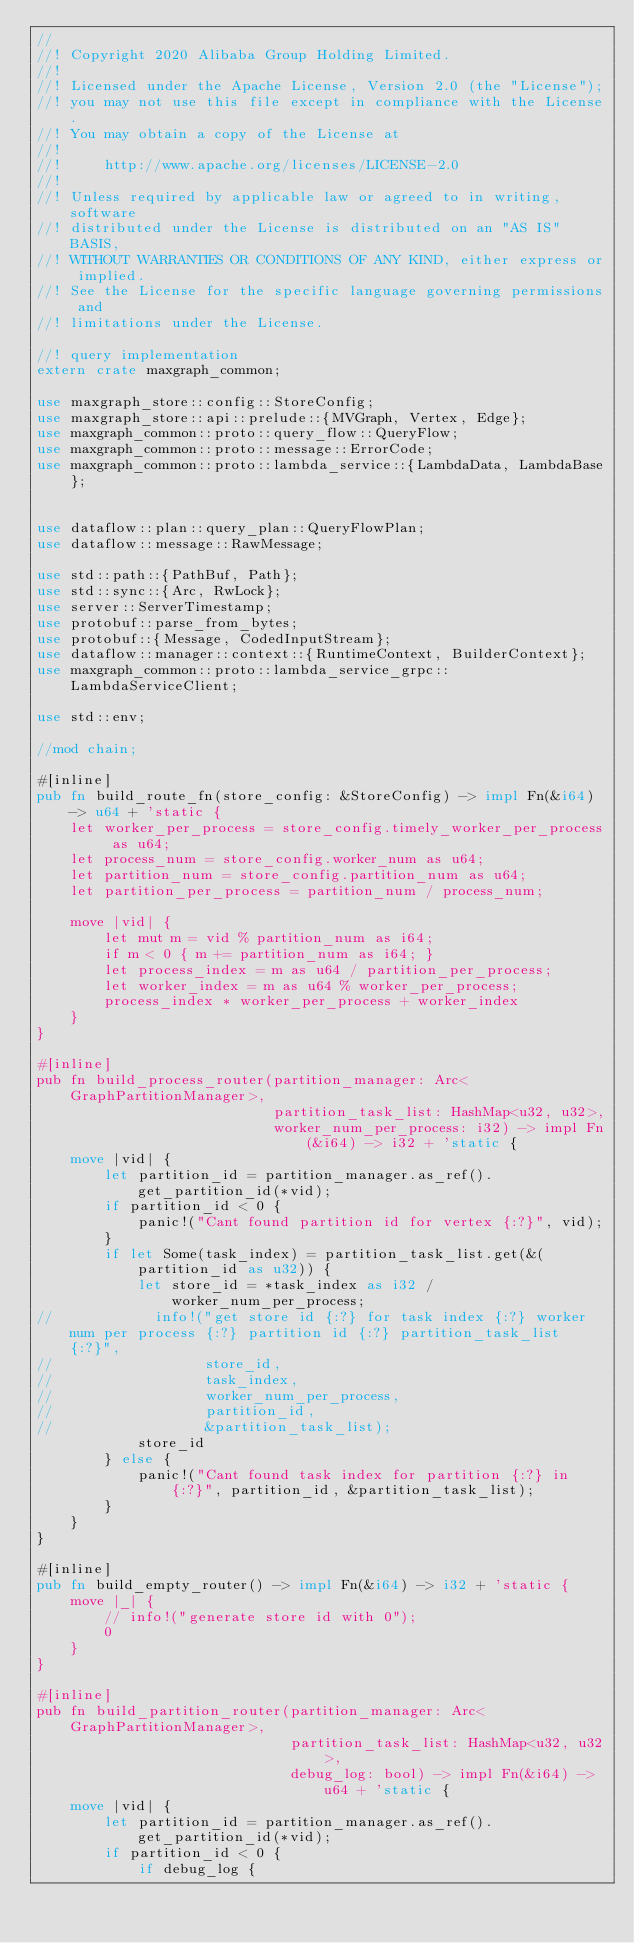Convert code to text. <code><loc_0><loc_0><loc_500><loc_500><_Rust_>//
//! Copyright 2020 Alibaba Group Holding Limited.
//! 
//! Licensed under the Apache License, Version 2.0 (the "License");
//! you may not use this file except in compliance with the License.
//! You may obtain a copy of the License at
//! 
//!     http://www.apache.org/licenses/LICENSE-2.0
//! 
//! Unless required by applicable law or agreed to in writing, software
//! distributed under the License is distributed on an "AS IS" BASIS,
//! WITHOUT WARRANTIES OR CONDITIONS OF ANY KIND, either express or implied.
//! See the License for the specific language governing permissions and
//! limitations under the License.

//! query implementation
extern crate maxgraph_common;

use maxgraph_store::config::StoreConfig;
use maxgraph_store::api::prelude::{MVGraph, Vertex, Edge};
use maxgraph_common::proto::query_flow::QueryFlow;
use maxgraph_common::proto::message::ErrorCode;
use maxgraph_common::proto::lambda_service::{LambdaData, LambdaBase};


use dataflow::plan::query_plan::QueryFlowPlan;
use dataflow::message::RawMessage;

use std::path::{PathBuf, Path};
use std::sync::{Arc, RwLock};
use server::ServerTimestamp;
use protobuf::parse_from_bytes;
use protobuf::{Message, CodedInputStream};
use dataflow::manager::context::{RuntimeContext, BuilderContext};
use maxgraph_common::proto::lambda_service_grpc::LambdaServiceClient;

use std::env;

//mod chain;

#[inline]
pub fn build_route_fn(store_config: &StoreConfig) -> impl Fn(&i64) -> u64 + 'static {
    let worker_per_process = store_config.timely_worker_per_process as u64;
    let process_num = store_config.worker_num as u64;
    let partition_num = store_config.partition_num as u64;
    let partition_per_process = partition_num / process_num;

    move |vid| {
        let mut m = vid % partition_num as i64;
        if m < 0 { m += partition_num as i64; }
        let process_index = m as u64 / partition_per_process;
        let worker_index = m as u64 % worker_per_process;
        process_index * worker_per_process + worker_index
    }
}

#[inline]
pub fn build_process_router(partition_manager: Arc<GraphPartitionManager>,
                            partition_task_list: HashMap<u32, u32>,
                            worker_num_per_process: i32) -> impl Fn(&i64) -> i32 + 'static {
    move |vid| {
        let partition_id = partition_manager.as_ref().get_partition_id(*vid);
        if partition_id < 0 {
            panic!("Cant found partition id for vertex {:?}", vid);
        }
        if let Some(task_index) = partition_task_list.get(&(partition_id as u32)) {
            let store_id = *task_index as i32 / worker_num_per_process;
//            info!("get store id {:?} for task index {:?} worker num per process {:?} partition id {:?} partition_task_list {:?}",
//                  store_id,
//                  task_index,
//                  worker_num_per_process,
//                  partition_id,
//                  &partition_task_list);
            store_id
        } else {
            panic!("Cant found task index for partition {:?} in {:?}", partition_id, &partition_task_list);
        }
    }
}

#[inline]
pub fn build_empty_router() -> impl Fn(&i64) -> i32 + 'static {
    move |_| {
        // info!("generate store id with 0");
        0
    }
}

#[inline]
pub fn build_partition_router(partition_manager: Arc<GraphPartitionManager>,
                              partition_task_list: HashMap<u32, u32>,
                              debug_log: bool) -> impl Fn(&i64) -> u64 + 'static {
    move |vid| {
        let partition_id = partition_manager.as_ref().get_partition_id(*vid);
        if partition_id < 0 {
            if debug_log {</code> 